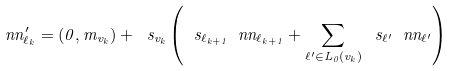<formula> <loc_0><loc_0><loc_500><loc_500>\ n n _ { \ell _ { k } } ^ { \prime } = ( 0 , m _ { v _ { k } } ) + \ s _ { v _ { k } } \left ( \ s _ { \ell _ { k + 1 } } \ n n _ { \ell _ { k + 1 } } + \sum _ { \ell ^ { \prime } \in L _ { 0 } ( v _ { k } ) } \ s _ { \ell ^ { \prime } } \ n n _ { \ell ^ { \prime } } \right )</formula> 